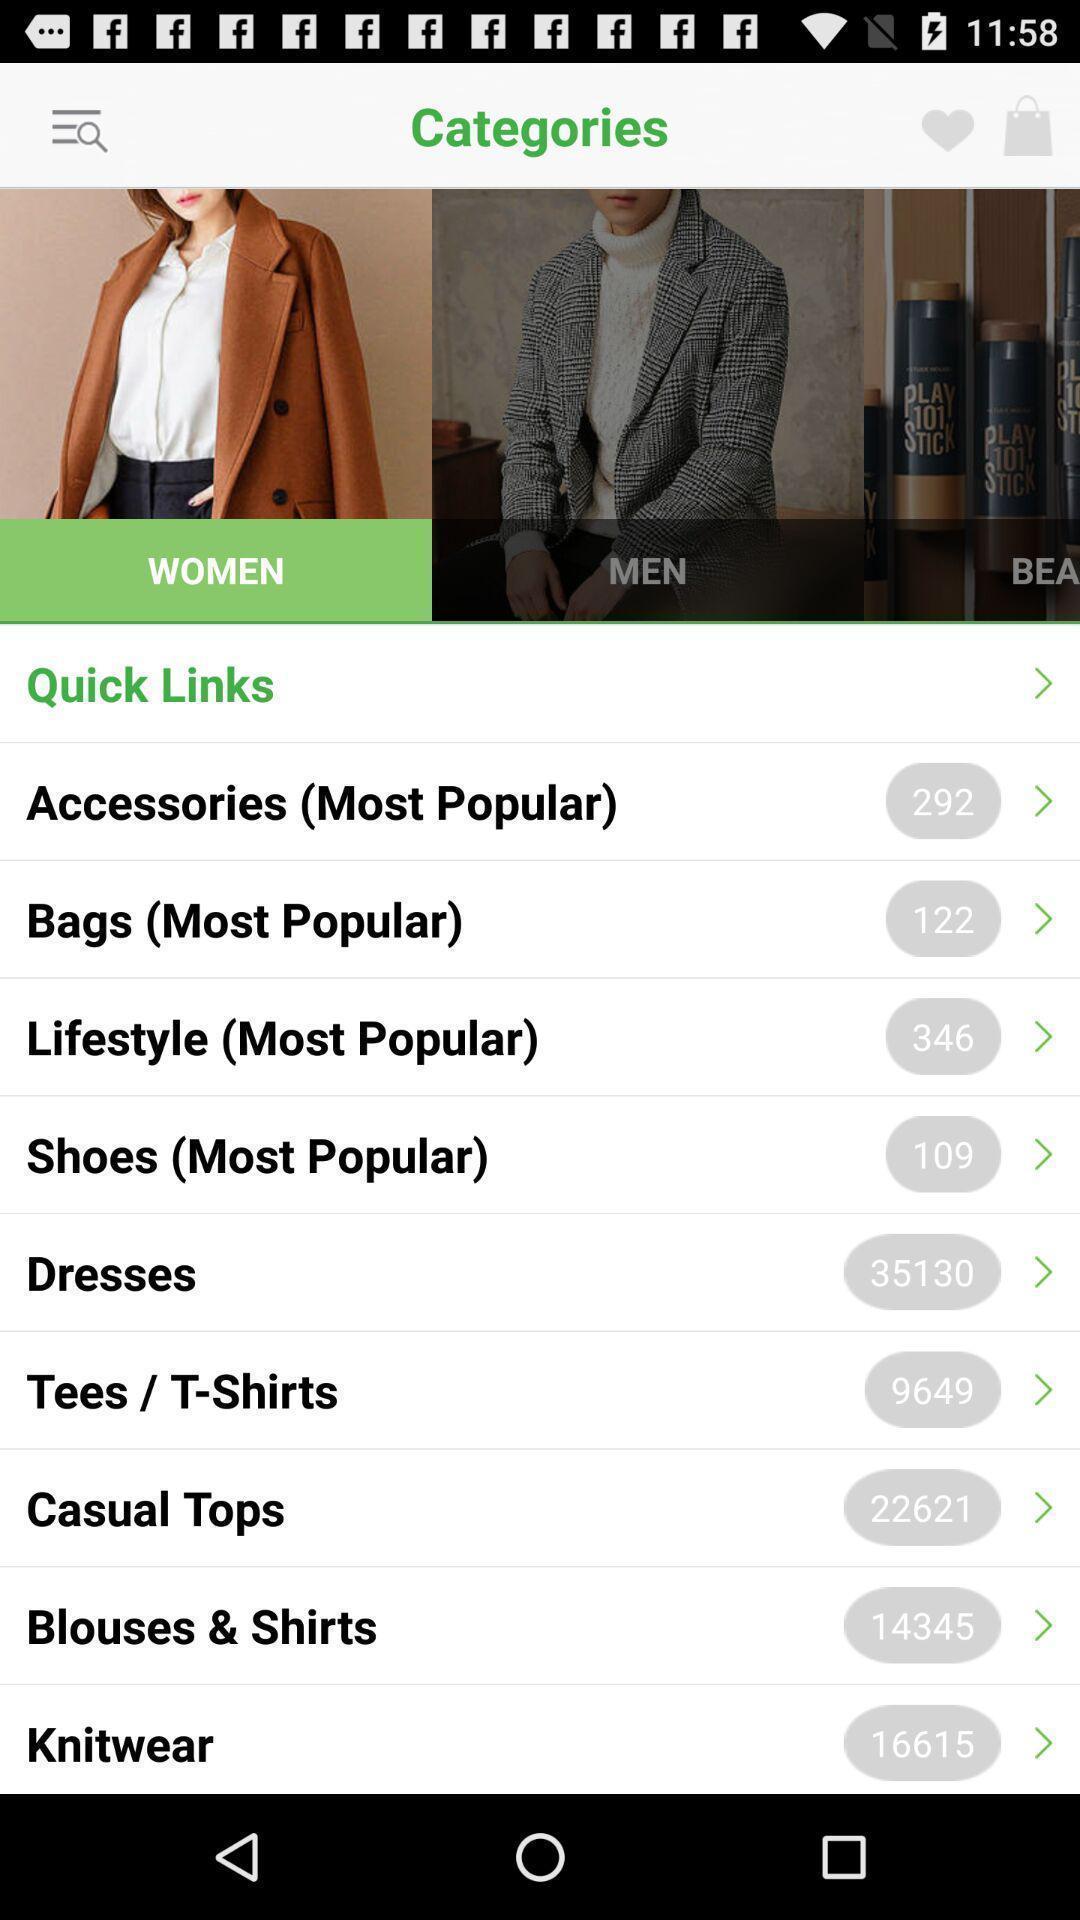What is the overall content of this screenshot? Screen displaying list of categories of items for women. 